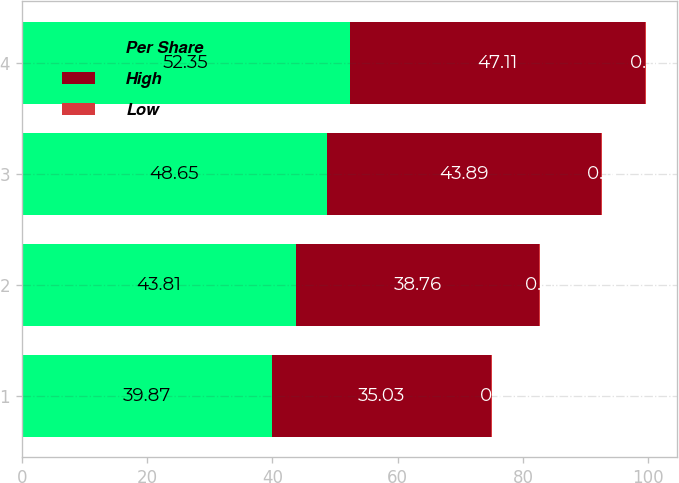Convert chart. <chart><loc_0><loc_0><loc_500><loc_500><stacked_bar_chart><ecel><fcel>1<fcel>2<fcel>3<fcel>4<nl><fcel>Per Share<fcel>39.87<fcel>43.81<fcel>48.65<fcel>52.35<nl><fcel>High<fcel>35.03<fcel>38.76<fcel>43.89<fcel>47.11<nl><fcel>Low<fcel>0.1<fcel>0.11<fcel>0.11<fcel>0.11<nl></chart> 